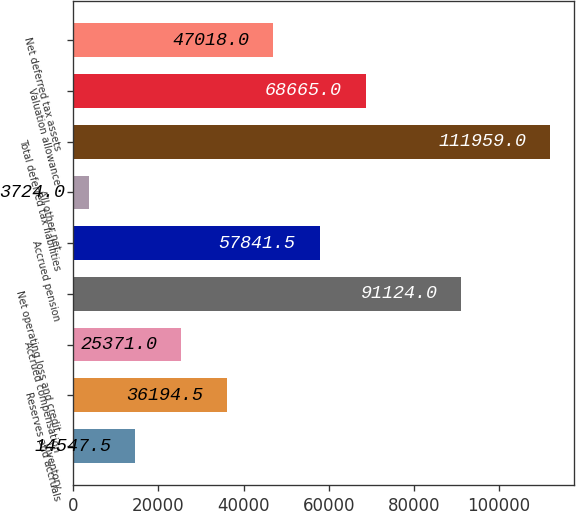Convert chart. <chart><loc_0><loc_0><loc_500><loc_500><bar_chart><fcel>Inventory<fcel>Reserves and accruals<fcel>Accrued compensation<fcel>Net operating loss and credit<fcel>Accrued pension<fcel>All other net<fcel>Total deferred tax liabilities<fcel>Valuation allowance<fcel>Net deferred tax assets<nl><fcel>14547.5<fcel>36194.5<fcel>25371<fcel>91124<fcel>57841.5<fcel>3724<fcel>111959<fcel>68665<fcel>47018<nl></chart> 